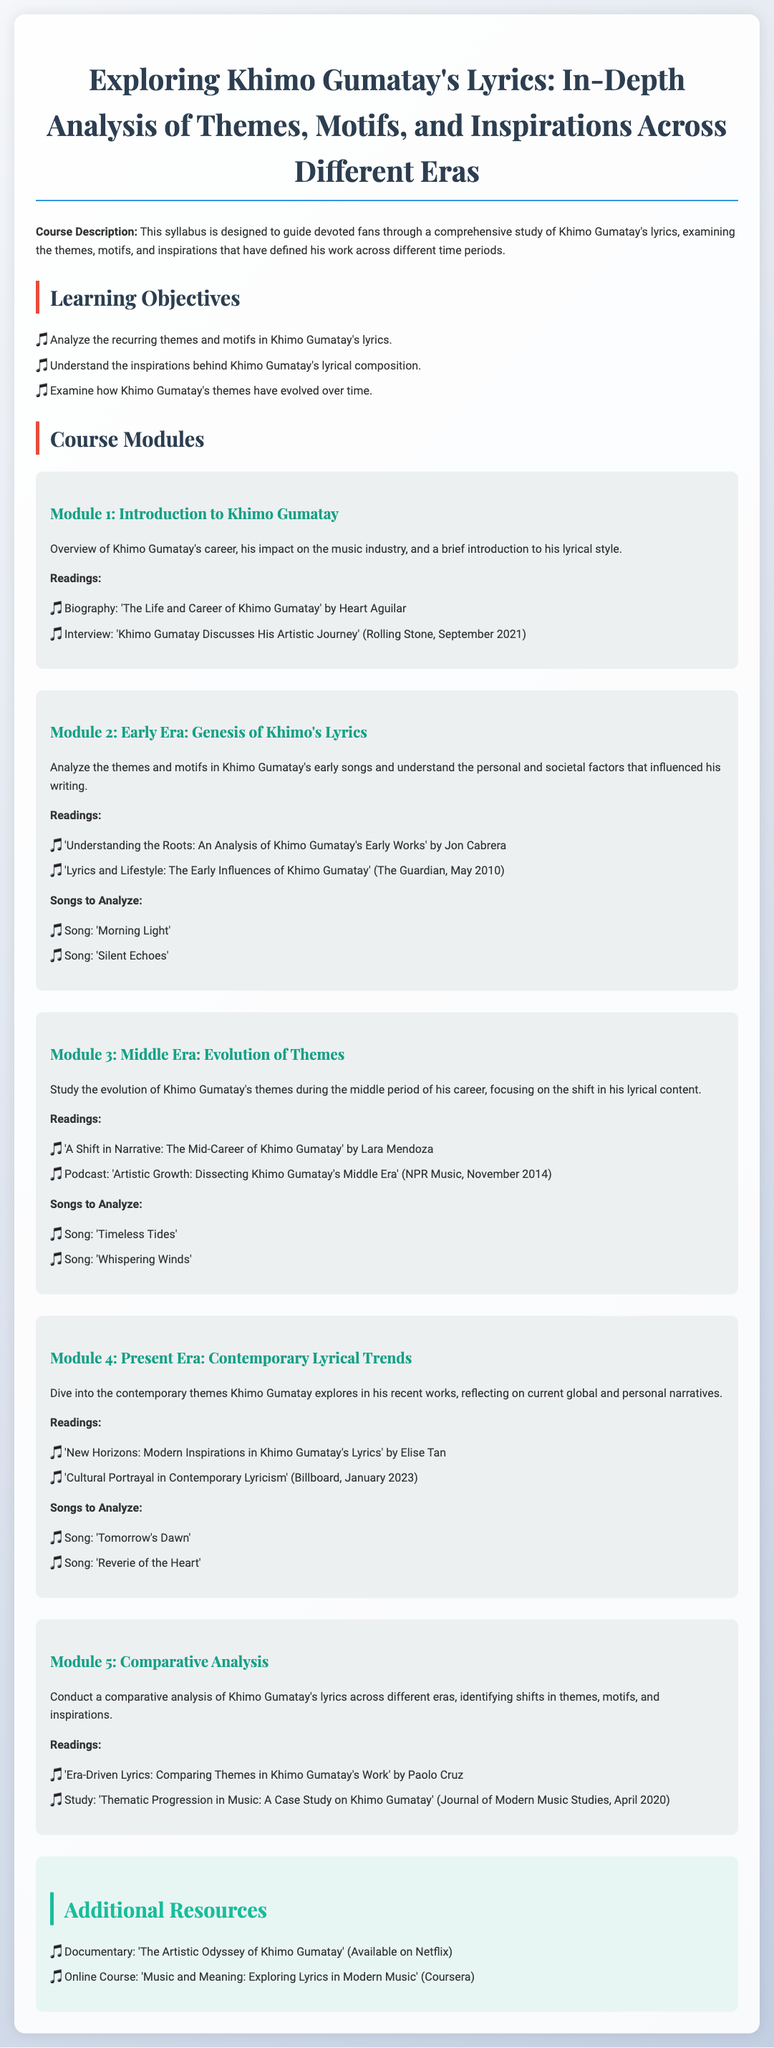What is the title of the syllabus? The title is clearly stated at the top of the document and is "Exploring Khimo Gumatay's Lyrics: In-Depth Analysis of Themes, Motifs, and Inspirations Across Different Eras."
Answer: Exploring Khimo Gumatay's Lyrics: In-Depth Analysis of Themes, Motifs, and Inspirations Across Different Eras Who wrote the biography suggested for reading in Module 1? The readings list in Module 1 names the author of the biography as Heart Aguilar.
Answer: Heart Aguilar How many modules are included in the syllabus? The syllabus lists five distinct modules, providing structured content for the course.
Answer: 5 What is the focus of Module 3? Module 3's description states the focus is on "Evolution of Themes" during Khimo Gumatay's middle period of his career.
Answer: Evolution of Themes Which song is analyzed in Module 4? Module 4 lists "Tomorrow's Dawn" as one of the songs to be analyzed under contemporary themes.
Answer: Tomorrow's Dawn What is one additional resource suggested in the syllabus? The additional resources section includes the documentary titled "The Artistic Odyssey of Khimo Gumatay."
Answer: The Artistic Odyssey of Khimo Gumatay What type of analysis is conducted in Module 5? The description of Module 5 indicates that it involves "Comparative Analysis" of lyrics across different eras.
Answer: Comparative Analysis What is the name of the online course mentioned as an additional resource? The additional resources section references the online course titled "Music and Meaning: Exploring Lyrics in Modern Music."
Answer: Music and Meaning: Exploring Lyrics in Modern Music 